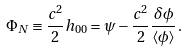<formula> <loc_0><loc_0><loc_500><loc_500>\Phi _ { N } \equiv \frac { c ^ { 2 } } { 2 } h _ { 0 0 } = \psi - \frac { c ^ { 2 } } { 2 } \frac { \delta \phi } { \langle \phi \rangle } \, .</formula> 